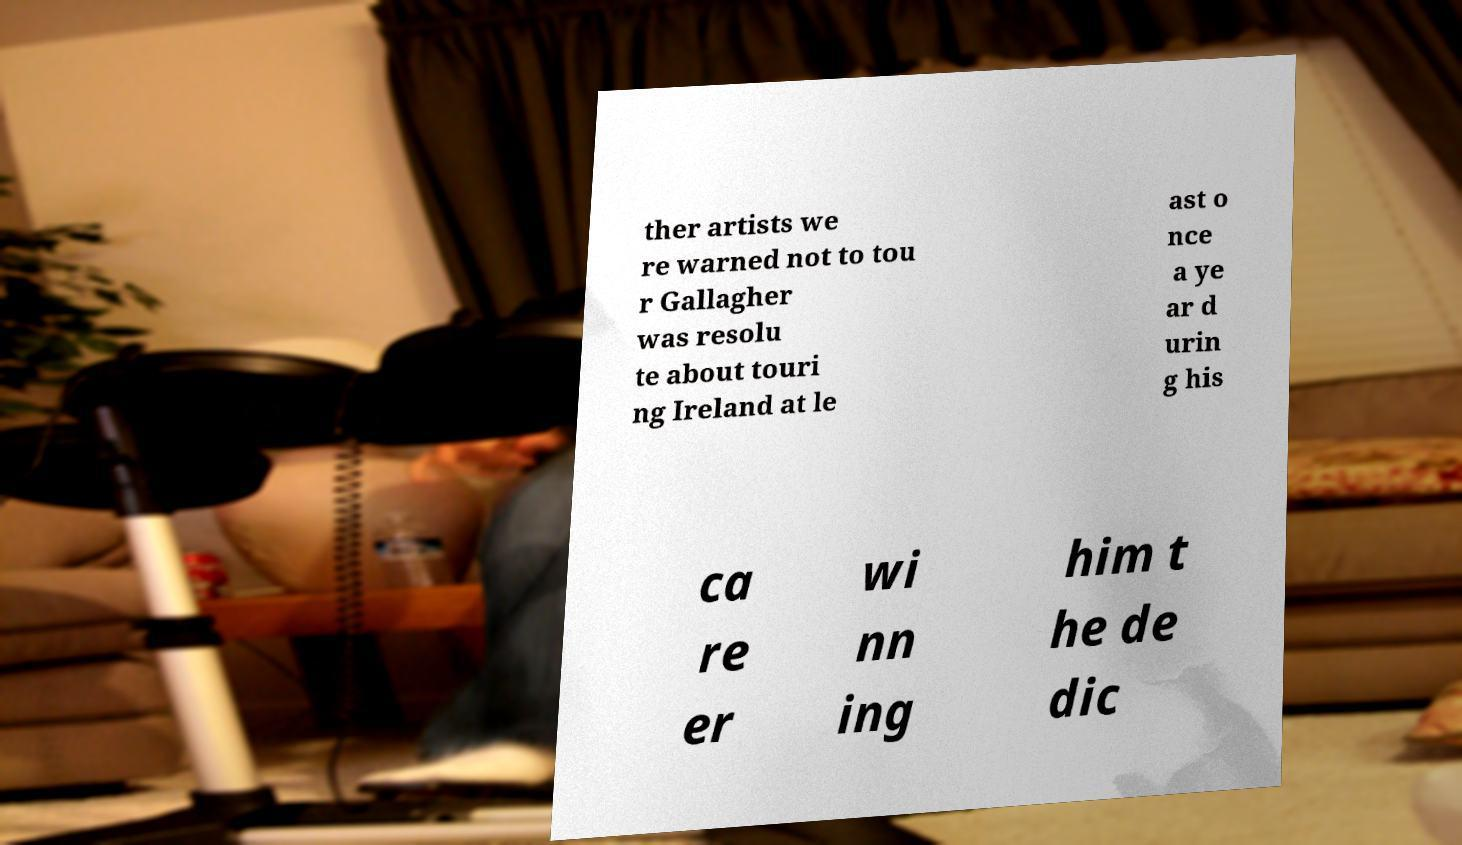Please identify and transcribe the text found in this image. ther artists we re warned not to tou r Gallagher was resolu te about touri ng Ireland at le ast o nce a ye ar d urin g his ca re er wi nn ing him t he de dic 